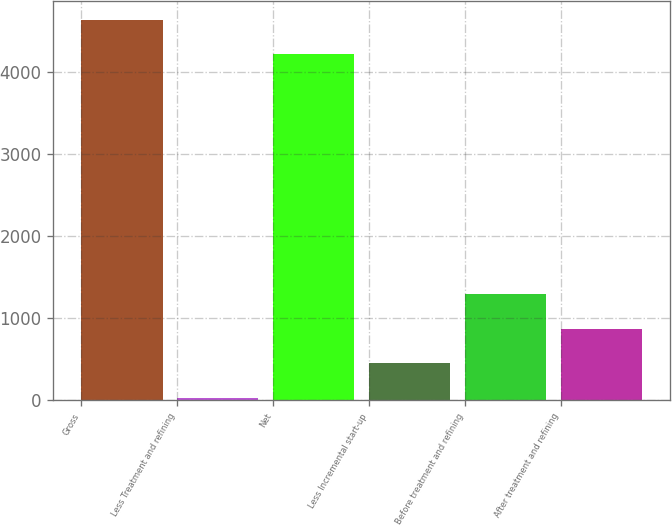<chart> <loc_0><loc_0><loc_500><loc_500><bar_chart><fcel>Gross<fcel>Less Treatment and refining<fcel>Net<fcel>Less Incremental start-up<fcel>Before treatment and refining<fcel>After treatment and refining<nl><fcel>4632.1<fcel>30<fcel>4211<fcel>451.1<fcel>1293.3<fcel>872.2<nl></chart> 